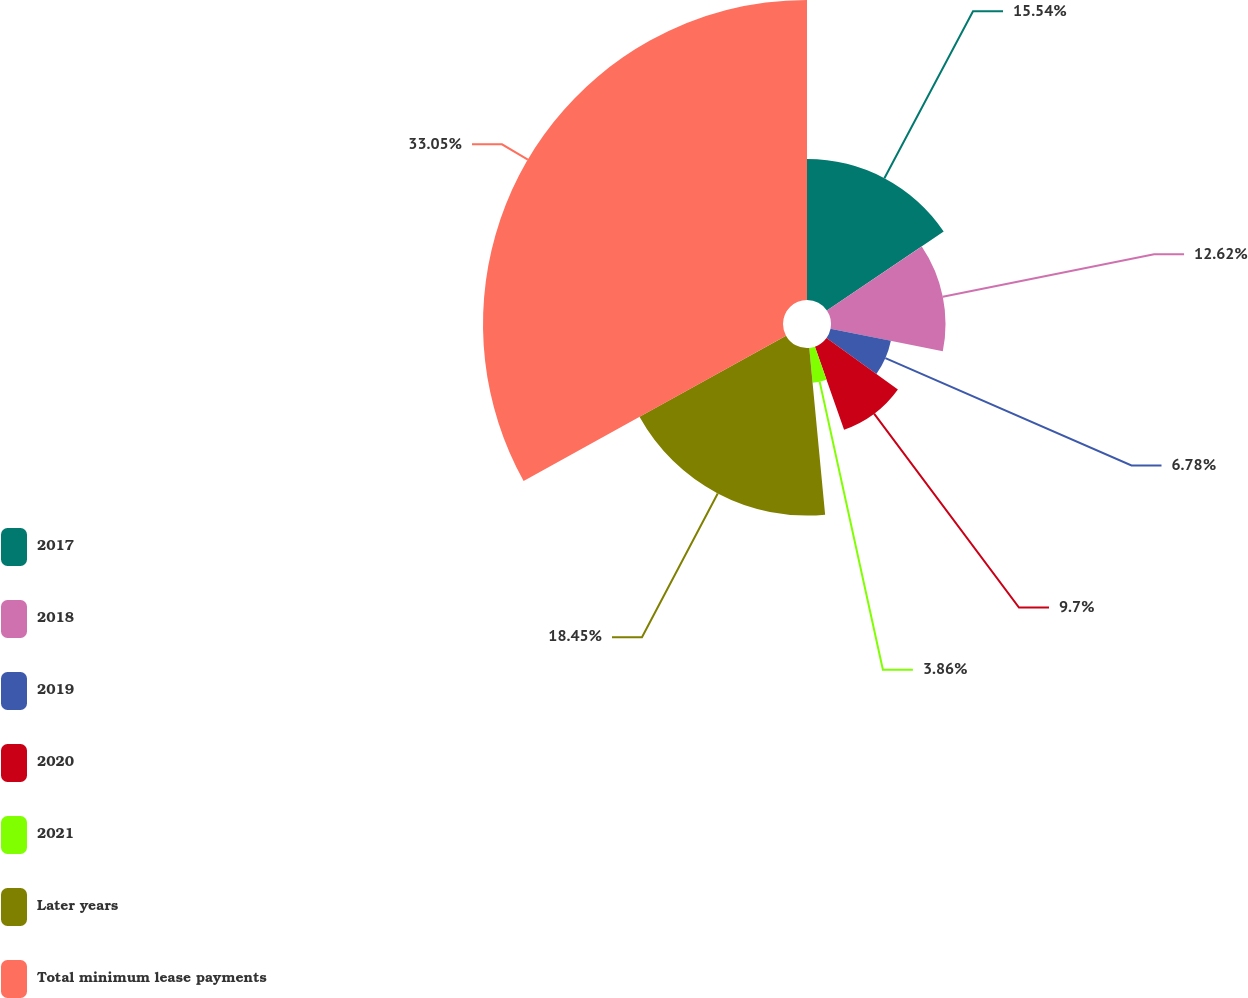<chart> <loc_0><loc_0><loc_500><loc_500><pie_chart><fcel>2017<fcel>2018<fcel>2019<fcel>2020<fcel>2021<fcel>Later years<fcel>Total minimum lease payments<nl><fcel>15.54%<fcel>12.62%<fcel>6.78%<fcel>9.7%<fcel>3.86%<fcel>18.46%<fcel>33.06%<nl></chart> 